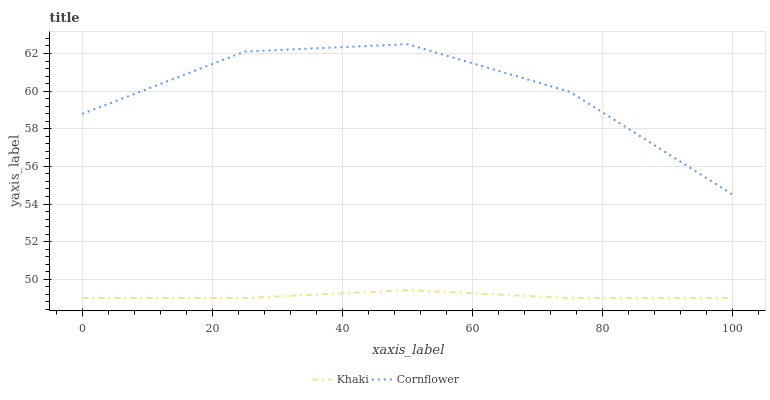Does Khaki have the minimum area under the curve?
Answer yes or no. Yes. Does Cornflower have the maximum area under the curve?
Answer yes or no. Yes. Does Khaki have the maximum area under the curve?
Answer yes or no. No. Is Khaki the smoothest?
Answer yes or no. Yes. Is Cornflower the roughest?
Answer yes or no. Yes. Is Khaki the roughest?
Answer yes or no. No. Does Khaki have the lowest value?
Answer yes or no. Yes. Does Cornflower have the highest value?
Answer yes or no. Yes. Does Khaki have the highest value?
Answer yes or no. No. Is Khaki less than Cornflower?
Answer yes or no. Yes. Is Cornflower greater than Khaki?
Answer yes or no. Yes. Does Khaki intersect Cornflower?
Answer yes or no. No. 